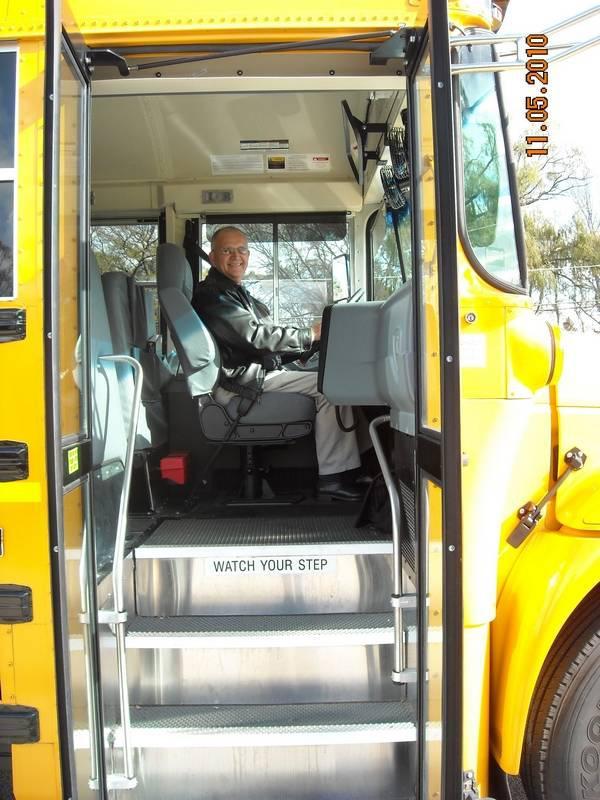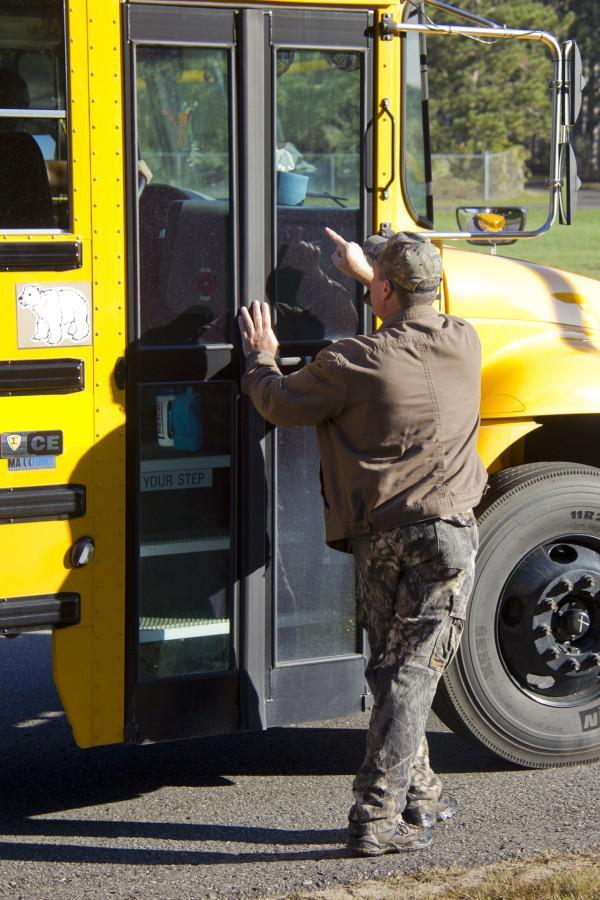The first image is the image on the left, the second image is the image on the right. Considering the images on both sides, is "One of the buses' passenger door is open." valid? Answer yes or no. Yes. The first image is the image on the left, the second image is the image on the right. Evaluate the accuracy of this statement regarding the images: "An image shows an open bus door viewed head-on, with steps leading inside and the driver seat facing rightward.". Is it true? Answer yes or no. Yes. 